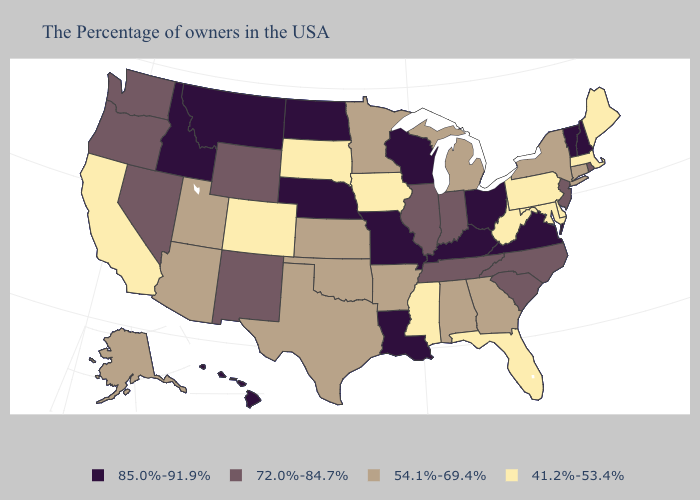Name the states that have a value in the range 72.0%-84.7%?
Write a very short answer. Rhode Island, New Jersey, North Carolina, South Carolina, Indiana, Tennessee, Illinois, Wyoming, New Mexico, Nevada, Washington, Oregon. Name the states that have a value in the range 54.1%-69.4%?
Short answer required. Connecticut, New York, Georgia, Michigan, Alabama, Arkansas, Minnesota, Kansas, Oklahoma, Texas, Utah, Arizona, Alaska. What is the highest value in the South ?
Answer briefly. 85.0%-91.9%. Which states have the lowest value in the USA?
Give a very brief answer. Maine, Massachusetts, Delaware, Maryland, Pennsylvania, West Virginia, Florida, Mississippi, Iowa, South Dakota, Colorado, California. What is the value of Nevada?
Concise answer only. 72.0%-84.7%. Name the states that have a value in the range 72.0%-84.7%?
Concise answer only. Rhode Island, New Jersey, North Carolina, South Carolina, Indiana, Tennessee, Illinois, Wyoming, New Mexico, Nevada, Washington, Oregon. Does the first symbol in the legend represent the smallest category?
Be succinct. No. What is the value of Minnesota?
Quick response, please. 54.1%-69.4%. Which states have the lowest value in the USA?
Short answer required. Maine, Massachusetts, Delaware, Maryland, Pennsylvania, West Virginia, Florida, Mississippi, Iowa, South Dakota, Colorado, California. Does Maryland have the same value as Mississippi?
Quick response, please. Yes. Does the map have missing data?
Keep it brief. No. Among the states that border Wyoming , which have the highest value?
Be succinct. Nebraska, Montana, Idaho. Name the states that have a value in the range 72.0%-84.7%?
Short answer required. Rhode Island, New Jersey, North Carolina, South Carolina, Indiana, Tennessee, Illinois, Wyoming, New Mexico, Nevada, Washington, Oregon. Does Massachusetts have the lowest value in the Northeast?
Concise answer only. Yes. 